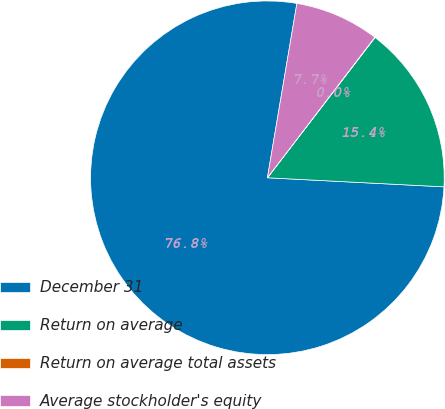<chart> <loc_0><loc_0><loc_500><loc_500><pie_chart><fcel>December 31<fcel>Return on average<fcel>Return on average total assets<fcel>Average stockholder's equity<nl><fcel>76.85%<fcel>15.4%<fcel>0.03%<fcel>7.72%<nl></chart> 